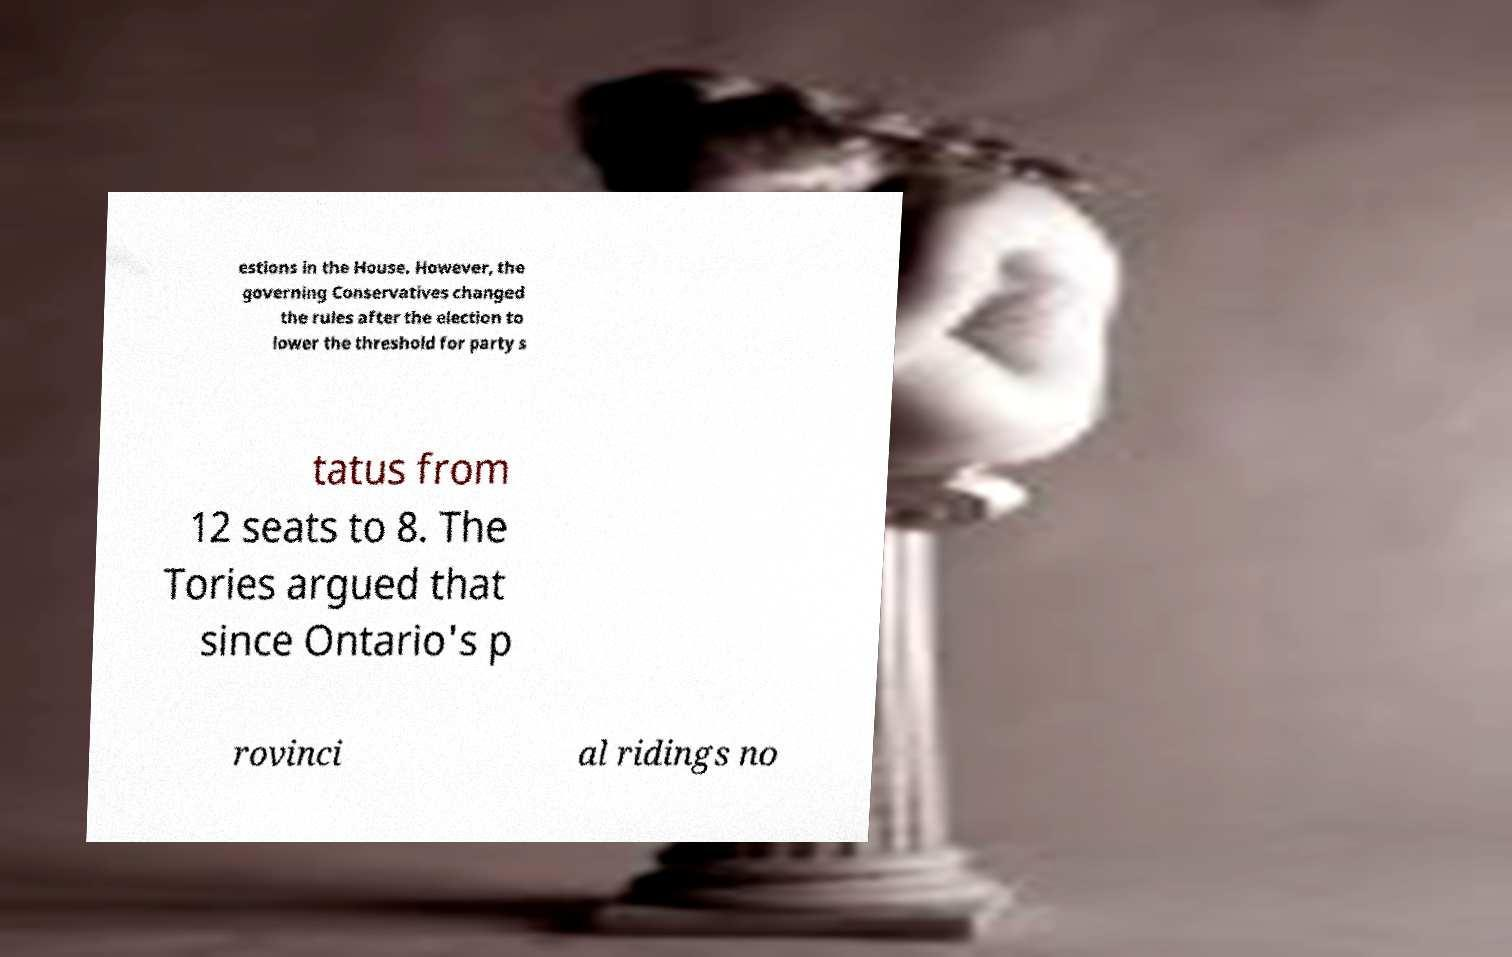Can you accurately transcribe the text from the provided image for me? estions in the House. However, the governing Conservatives changed the rules after the election to lower the threshold for party s tatus from 12 seats to 8. The Tories argued that since Ontario's p rovinci al ridings no 